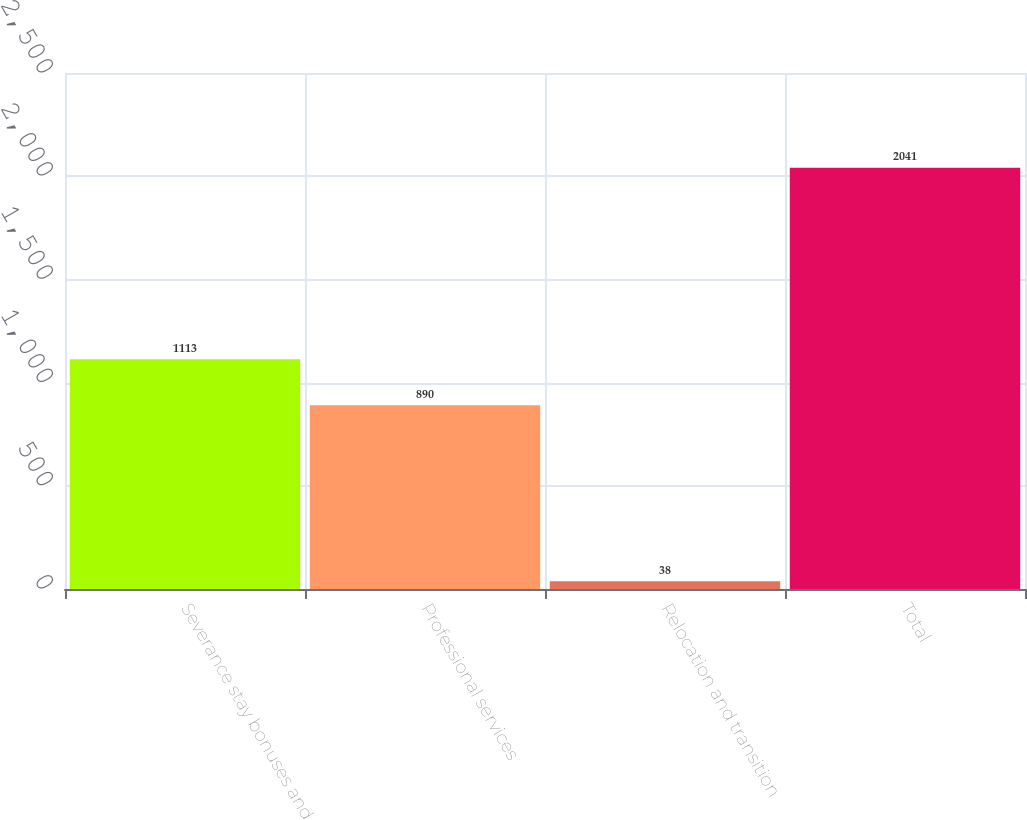<chart> <loc_0><loc_0><loc_500><loc_500><bar_chart><fcel>Severance stay bonuses and<fcel>Professional services<fcel>Relocation and transition<fcel>Total<nl><fcel>1113<fcel>890<fcel>38<fcel>2041<nl></chart> 